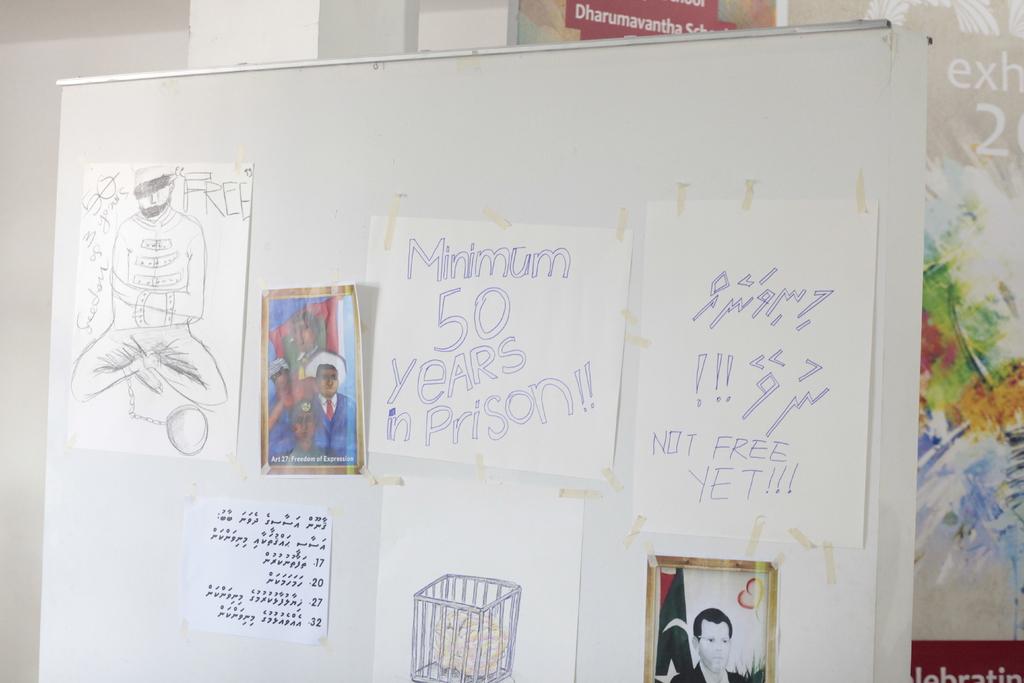Not free when?
Your answer should be very brief. Yet. How many years minimum does the paper say for prison?
Give a very brief answer. 50. 